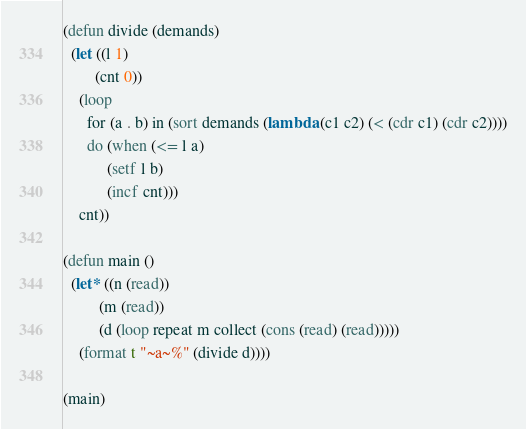<code> <loc_0><loc_0><loc_500><loc_500><_Lisp_>(defun divide (demands)
  (let ((l 1)
        (cnt 0))
    (loop
      for (a . b) in (sort demands (lambda (c1 c2) (< (cdr c1) (cdr c2))))
      do (when (<= l a)
           (setf l b)
           (incf cnt)))
    cnt))

(defun main ()
  (let* ((n (read))
         (m (read))
         (d (loop repeat m collect (cons (read) (read)))))
    (format t "~a~%" (divide d))))

(main)</code> 